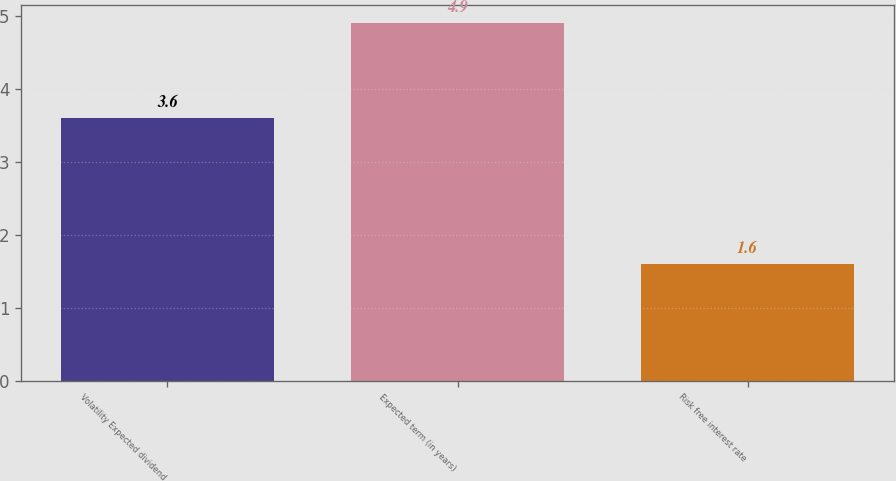Convert chart. <chart><loc_0><loc_0><loc_500><loc_500><bar_chart><fcel>Volatility Expected dividend<fcel>Expected term (in years)<fcel>Risk free interest rate<nl><fcel>3.6<fcel>4.9<fcel>1.6<nl></chart> 